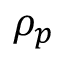Convert formula to latex. <formula><loc_0><loc_0><loc_500><loc_500>\rho _ { p }</formula> 